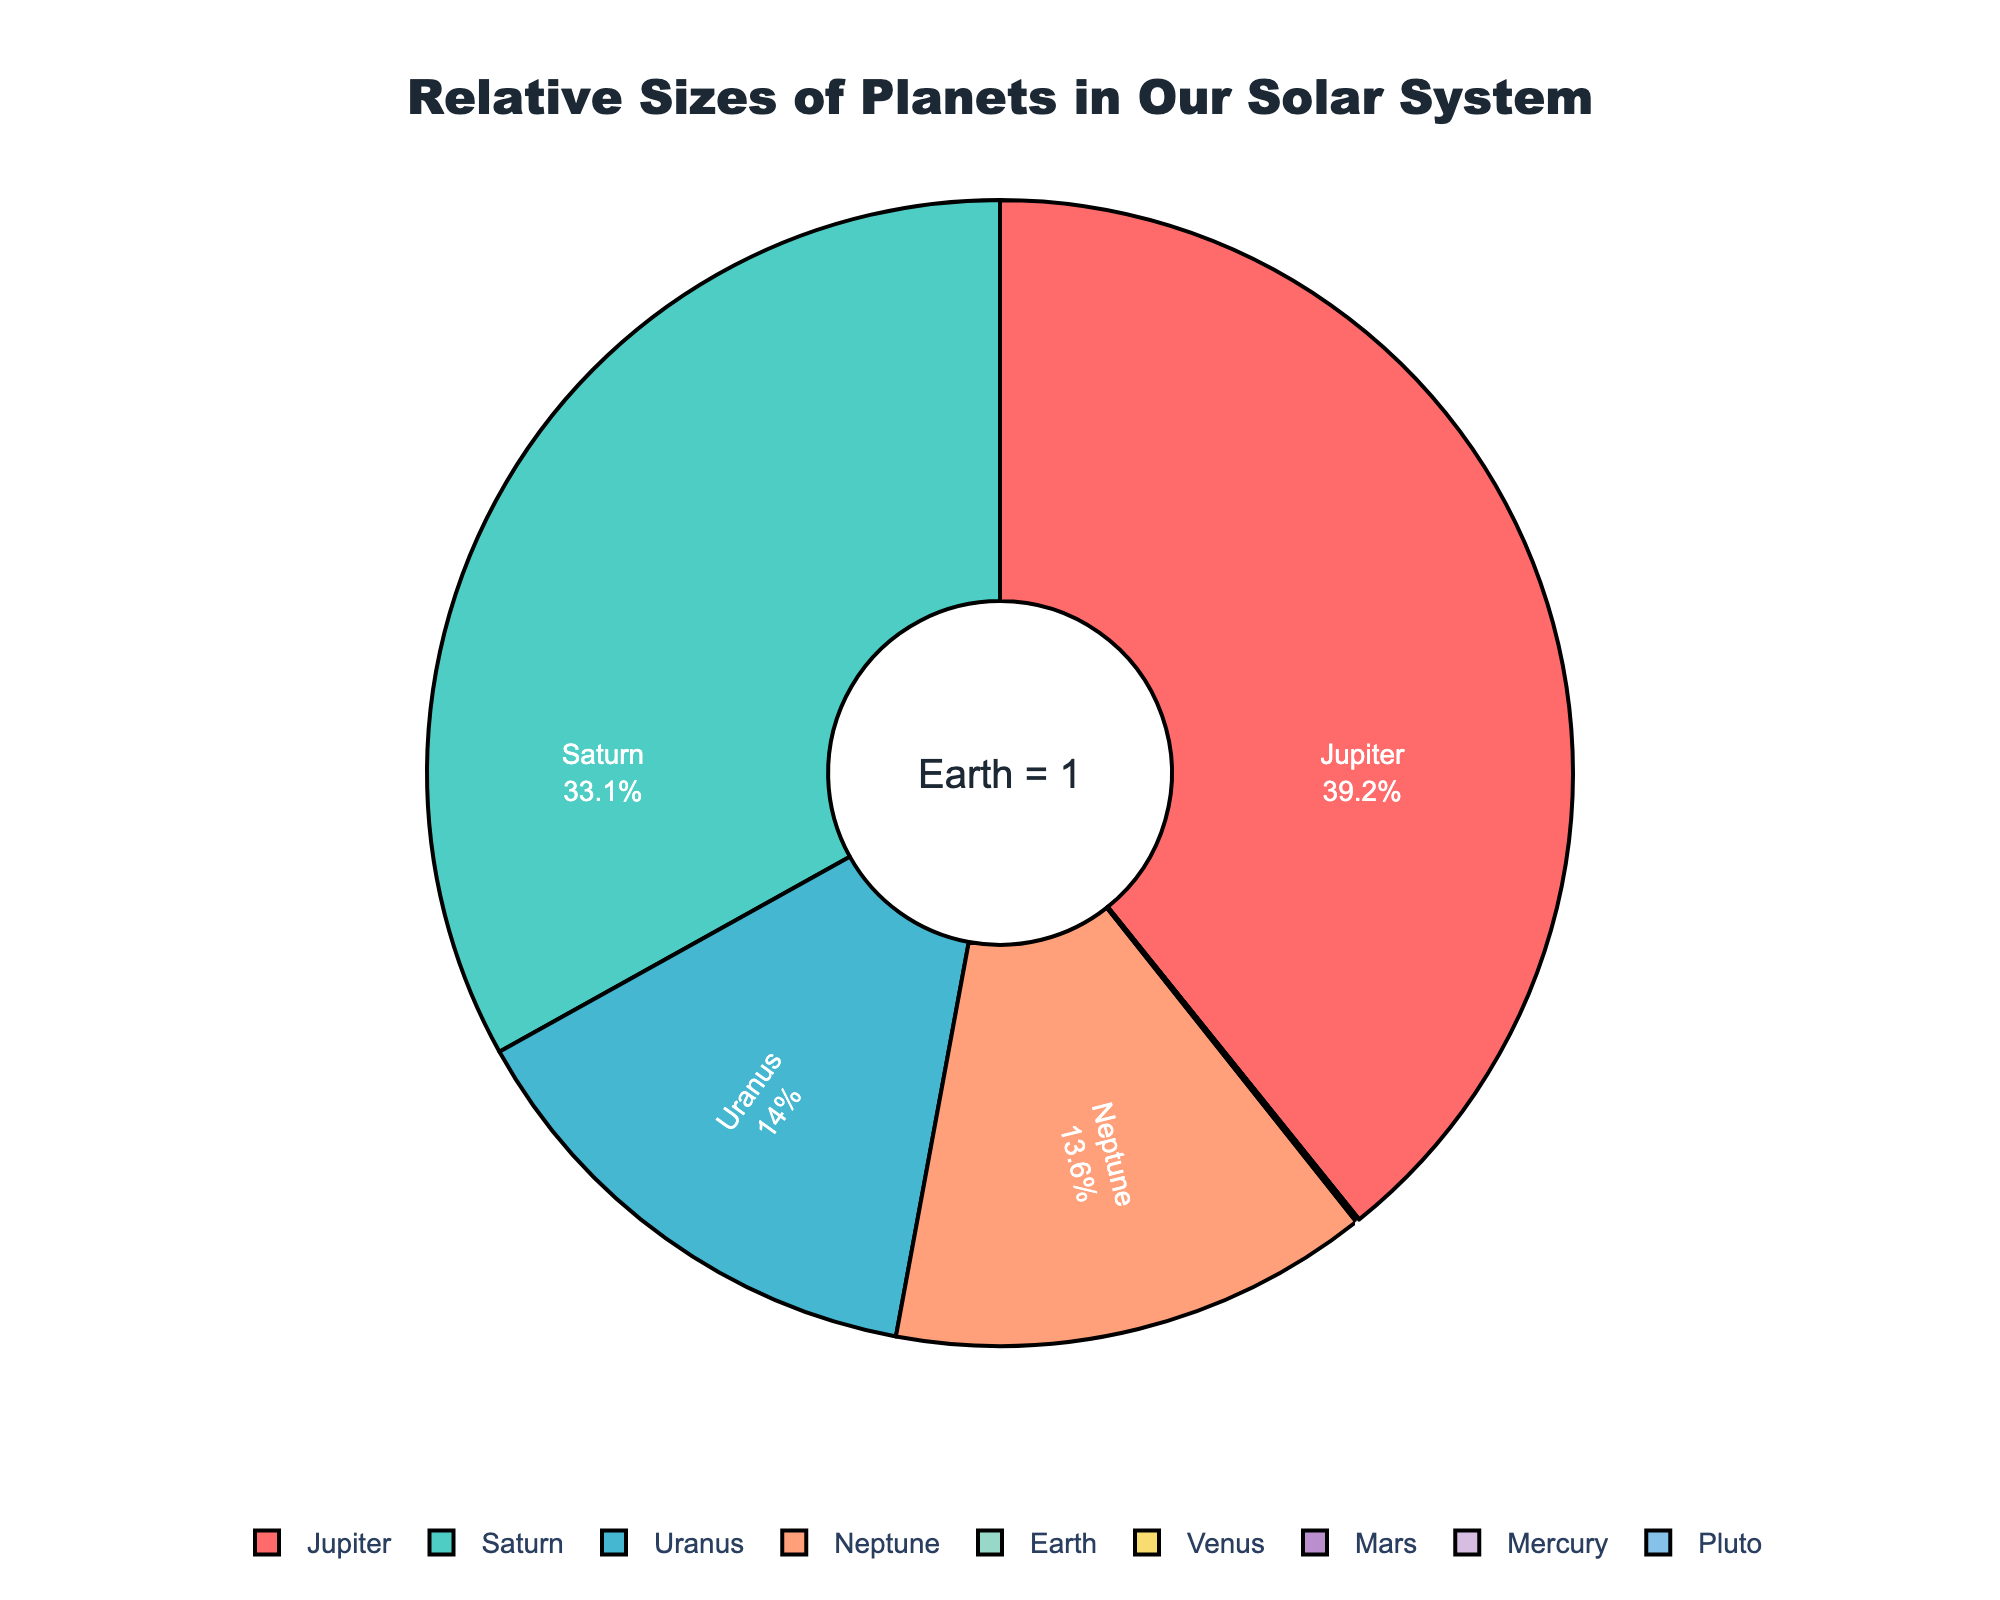How many times larger is Jupiter compared to Earth? Jupiter's size is listed as 1120.0, and Earth's size is 1.0. To find how many times larger Jupiter is than Earth, divide the size of Jupiter by the size of Earth: 1120.0 / 1.0 = 1120.0.
Answer: 1120.0 Which planet is the smallest compared to Earth and what is its size? From the data, Pluto has the smallest size relative to Earth, listed as 0.18.
Answer: Pluto, 0.18 What is the combined relative size of Saturn and Neptune compared to Earth? Saturn's size is 945.0 and Neptune's size is 388.0. Adding them together gives 945.0 + 388.0 = 1333.0.
Answer: 1333.0 If you combine the relative sizes of Mars and Mercury, how do they compare to Uranus? Mars' size is 0.53 and Mercury's size is 0.38. Combined, they are 0.53 + 0.38 = 0.91. Uranus' size is 400.0. Comparing, 400.0 is much larger than 0.91.
Answer: Uranus is much larger How much larger is Venus than Pluto? Venus' size is 0.95 and Pluto's size is 0.18. To find how much larger Venus is, subtract Pluto's size from Venus' size: 0.95 - 0.18 = 0.77.
Answer: 0.77 Which planets have sizes less than 1 (Earth's size)? Planets with sizes less than 1 are Venus (0.95), Mars (0.53), Mercury (0.38), and Pluto (0.18).
Answer: Venus, Mars, Mercury, Pluto What percentage of the total pie does Jupiter represent? The percentage represented by a sector in a pie chart can be calculated by (value of the sector / sum of all sectors) * 100. Here, (1120.0 / (1120.0 + 945.0 + 400.0 + 388.0 + 1.0 + 0.95 + 0.53 + 0.38 + 0.18)) * 100 ≈ 39.23%.
Answer: ~39.23% Compare the relative sizes of Uranus and Neptune. What is the ratio of Uranus to Neptune? Uranus’ size is 400.0 and Neptune’s size is 388.0. The ratio is 400.0 / 388.0 ≈ 1.03, meaning Uranus is slightly larger than Neptune.
Answer: ~1.03 If Earth were the total pie, what would be the percentage representation of Mars? Based on the relative size, Mars is 0.53 times the size of Earth. Since Earth represents 100% of itself, Mars would be (0.53 / 1.0) * 100 = 53%.
Answer: 53% Could you list the planets in descending order of their sizes relative to Earth? The planets sorted by their sizes from largest to smallest are: Jupiter (1120.0), Saturn (945.0), Uranus (400.0), Neptune (388.0), Venus (0.95), Mars (0.53), Mercury (0.38), Pluto (0.18).
Answer: Jupiter, Saturn, Uranus, Neptune, Venus, Mars, Mercury, Pluto 